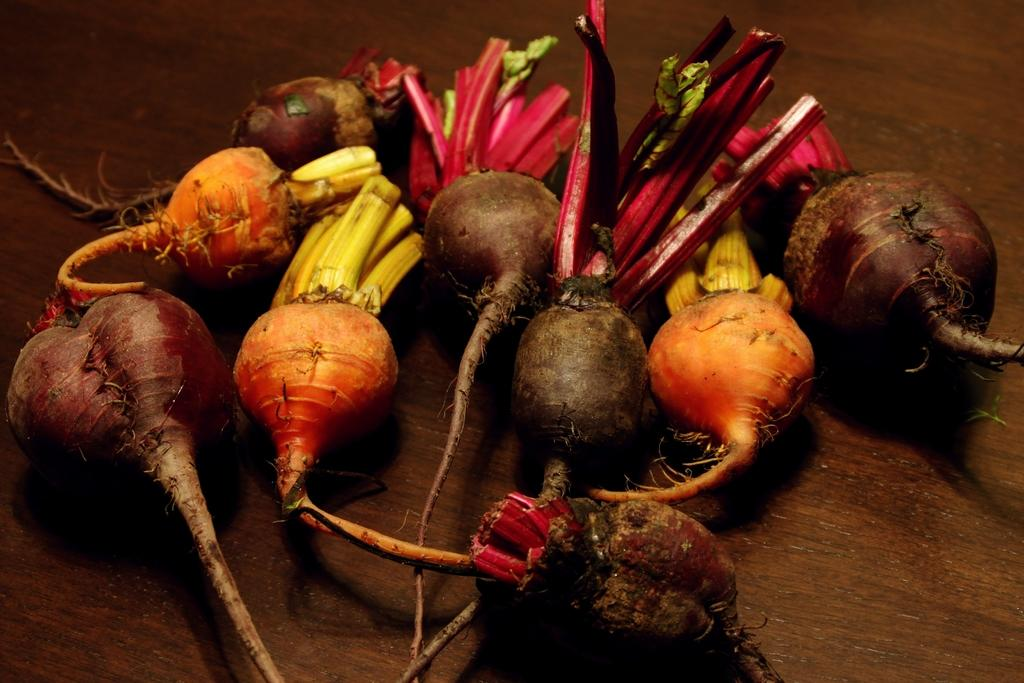What type of vegetable is present in the image? There are beetroots in the image. On what surface are the beetroots placed? The beetroots are placed on a brown table. What color is the table in the image? The table is brown. What can be seen in the background of the image? The background of the image is brown. What type of prose is being read by the mom in the image? There is no mom or prose present in the image; it only features beetroots on a brown table with a brown background. 